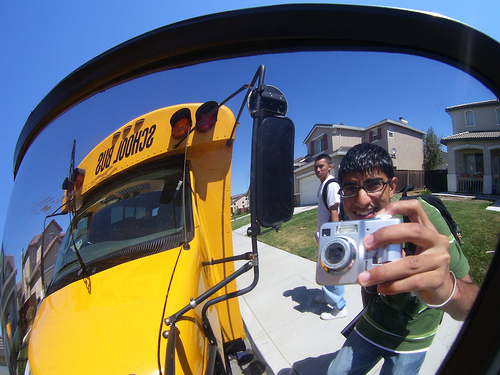What do you think the boys' favorite subjects might be, based on this image? Given the enthusiasm for taking pictures, the boy with the camera might have a keen interest in subjects like art or photography, perhaps enjoying the creative process. The boy in the background, engaged in the moment, might enjoy subjects that involve teamwork and social interaction, such as physical education or group projects in sociology. Describe a moment where the boys use the school bus in a different context outside of school. One weekend, the community organized a charity event, and the school bus was repurposed to transport volunteers. The boys eagerly joined the initiative. Riding the bus, they swapped their school supplies for gardening tools to help revamp a local park. The journey was filled with laughter, music, and a sense of purpose, making the bus a vessel of adventure and goodwill, contrasting its usual role in their daily school routine. 